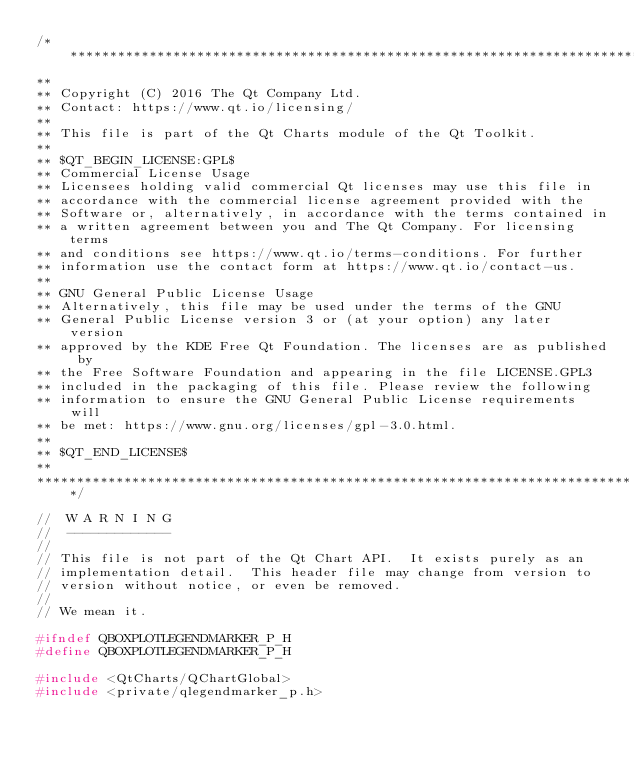Convert code to text. <code><loc_0><loc_0><loc_500><loc_500><_C_>/****************************************************************************
**
** Copyright (C) 2016 The Qt Company Ltd.
** Contact: https://www.qt.io/licensing/
**
** This file is part of the Qt Charts module of the Qt Toolkit.
**
** $QT_BEGIN_LICENSE:GPL$
** Commercial License Usage
** Licensees holding valid commercial Qt licenses may use this file in
** accordance with the commercial license agreement provided with the
** Software or, alternatively, in accordance with the terms contained in
** a written agreement between you and The Qt Company. For licensing terms
** and conditions see https://www.qt.io/terms-conditions. For further
** information use the contact form at https://www.qt.io/contact-us.
**
** GNU General Public License Usage
** Alternatively, this file may be used under the terms of the GNU
** General Public License version 3 or (at your option) any later version
** approved by the KDE Free Qt Foundation. The licenses are as published by
** the Free Software Foundation and appearing in the file LICENSE.GPL3
** included in the packaging of this file. Please review the following
** information to ensure the GNU General Public License requirements will
** be met: https://www.gnu.org/licenses/gpl-3.0.html.
**
** $QT_END_LICENSE$
**
****************************************************************************/

//  W A R N I N G
//  -------------
//
// This file is not part of the Qt Chart API.  It exists purely as an
// implementation detail.  This header file may change from version to
// version without notice, or even be removed.
//
// We mean it.

#ifndef QBOXPLOTLEGENDMARKER_P_H
#define QBOXPLOTLEGENDMARKER_P_H

#include <QtCharts/QChartGlobal>
#include <private/qlegendmarker_p.h></code> 